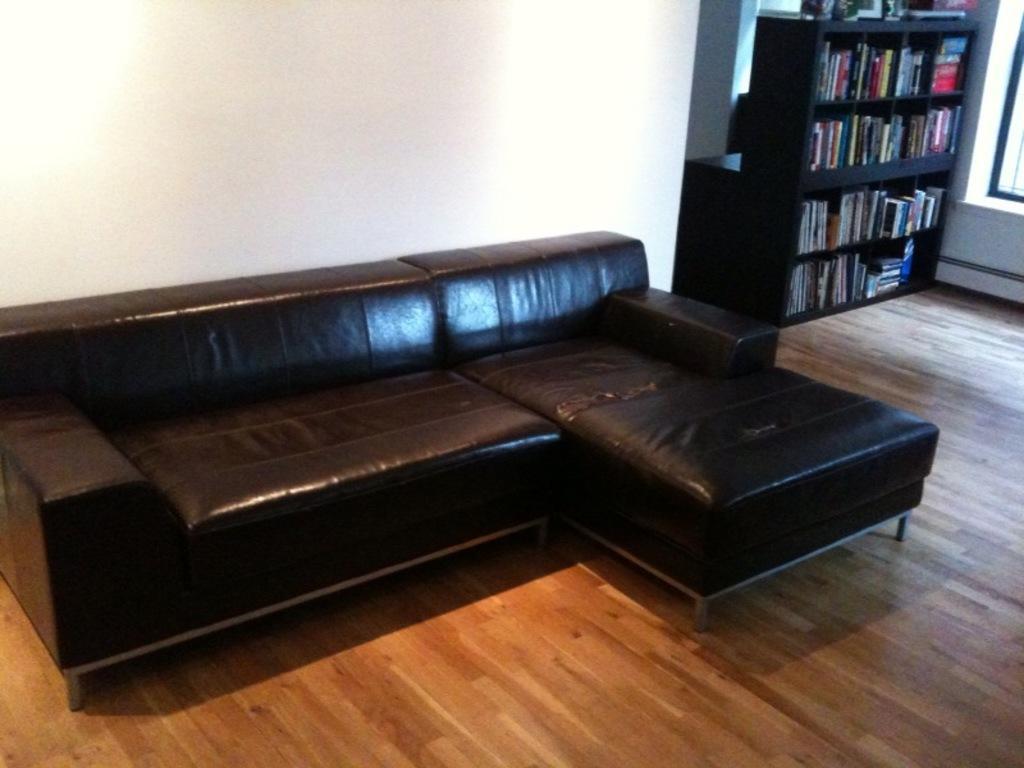Describe this image in one or two sentences. This is a picture taken in a room, this is a wooden floor on the floor there is a black color sofa. Background of this sofa is a white wall and a shelf there are the books. 